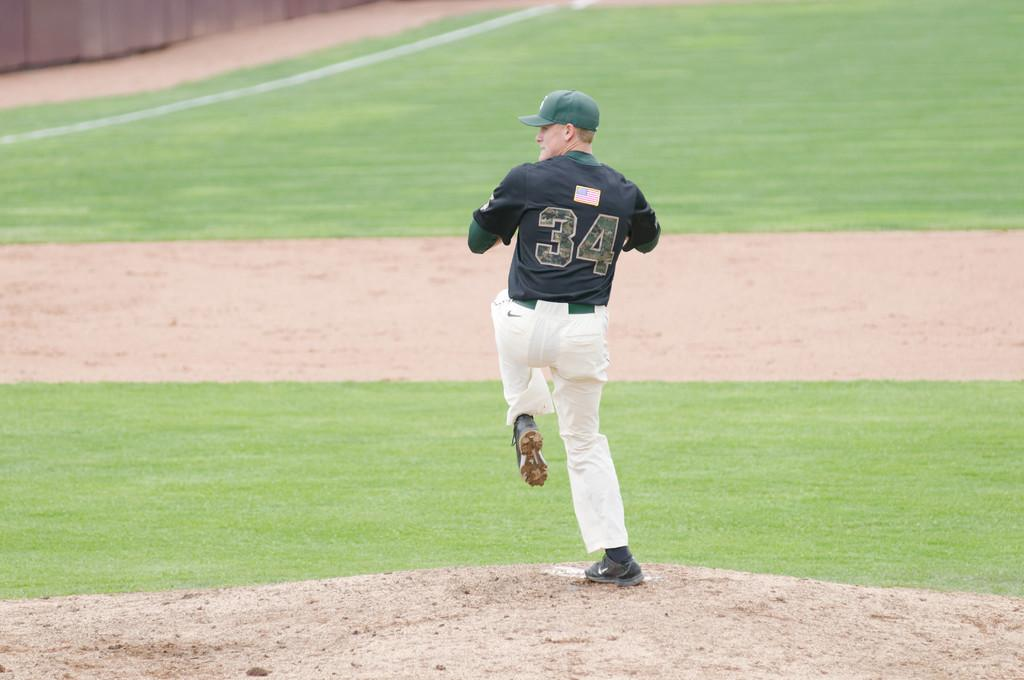What is the main subject of the image? There is a person in the image. What is the person wearing on their head? The person is wearing a green cap. What type of clothing is the person wearing on their lower body? The person is wearing a dress. What type of footwear is the person wearing? The person is wearing shoes. What surface is the person standing on? The person is standing on the ground. What type of brass instrument is the person playing in the image? There is no brass instrument present in the image; the person is only wearing a green cap, dress, shoes, and standing on the ground. 